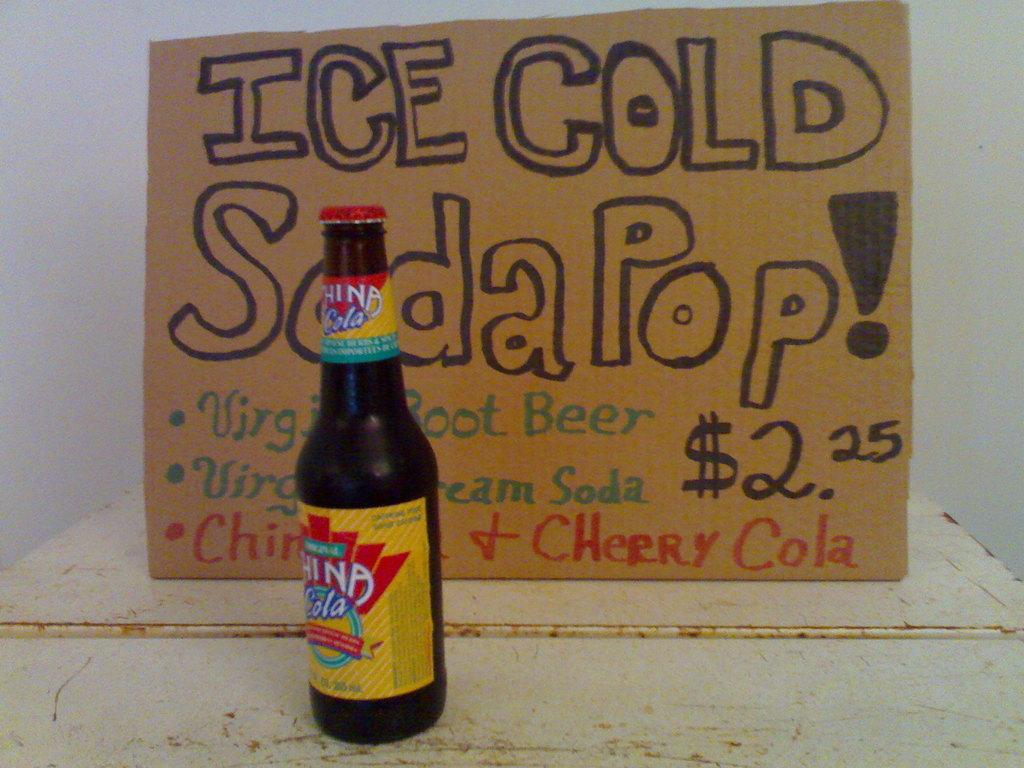<image>
Create a compact narrative representing the image presented. A bottle of China Cola with a written sign that says ice Cold Soda Pop. 